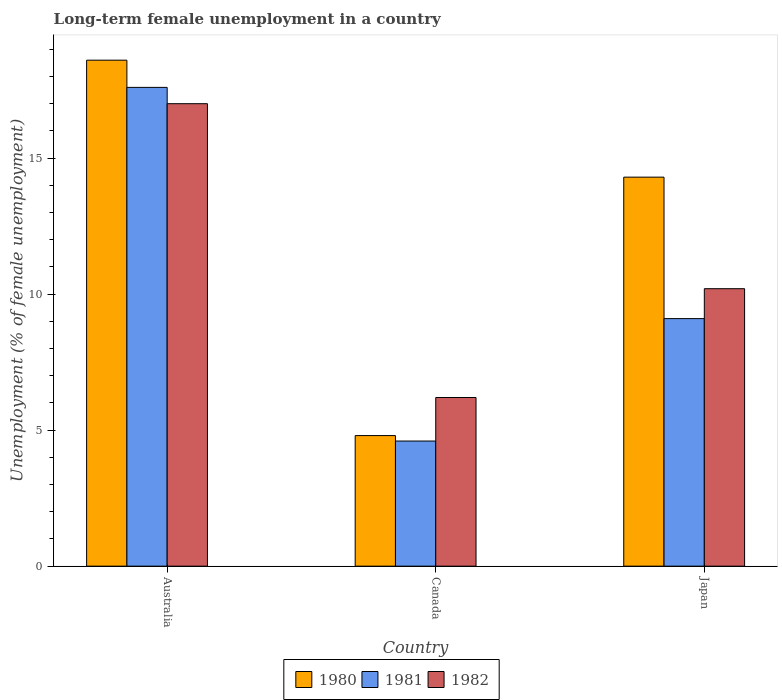How many different coloured bars are there?
Your answer should be compact. 3. How many groups of bars are there?
Provide a succinct answer. 3. Are the number of bars per tick equal to the number of legend labels?
Keep it short and to the point. Yes. Are the number of bars on each tick of the X-axis equal?
Offer a terse response. Yes. How many bars are there on the 3rd tick from the left?
Keep it short and to the point. 3. How many bars are there on the 3rd tick from the right?
Give a very brief answer. 3. In how many cases, is the number of bars for a given country not equal to the number of legend labels?
Your answer should be compact. 0. What is the percentage of long-term unemployed female population in 1981 in Japan?
Your answer should be compact. 9.1. Across all countries, what is the maximum percentage of long-term unemployed female population in 1980?
Give a very brief answer. 18.6. Across all countries, what is the minimum percentage of long-term unemployed female population in 1982?
Offer a very short reply. 6.2. In which country was the percentage of long-term unemployed female population in 1982 maximum?
Give a very brief answer. Australia. What is the total percentage of long-term unemployed female population in 1980 in the graph?
Make the answer very short. 37.7. What is the difference between the percentage of long-term unemployed female population in 1982 in Australia and that in Canada?
Your answer should be very brief. 10.8. What is the difference between the percentage of long-term unemployed female population in 1981 in Australia and the percentage of long-term unemployed female population in 1980 in Canada?
Provide a succinct answer. 12.8. What is the average percentage of long-term unemployed female population in 1982 per country?
Your answer should be very brief. 11.13. What is the difference between the percentage of long-term unemployed female population of/in 1981 and percentage of long-term unemployed female population of/in 1982 in Canada?
Offer a terse response. -1.6. In how many countries, is the percentage of long-term unemployed female population in 1982 greater than 9 %?
Your answer should be very brief. 2. What is the ratio of the percentage of long-term unemployed female population in 1982 in Australia to that in Japan?
Give a very brief answer. 1.67. What is the difference between the highest and the second highest percentage of long-term unemployed female population in 1980?
Your response must be concise. 13.8. What is the difference between the highest and the lowest percentage of long-term unemployed female population in 1980?
Ensure brevity in your answer.  13.8. In how many countries, is the percentage of long-term unemployed female population in 1980 greater than the average percentage of long-term unemployed female population in 1980 taken over all countries?
Offer a very short reply. 2. Is the sum of the percentage of long-term unemployed female population in 1980 in Australia and Canada greater than the maximum percentage of long-term unemployed female population in 1981 across all countries?
Offer a terse response. Yes. How many bars are there?
Your answer should be very brief. 9. Are all the bars in the graph horizontal?
Offer a very short reply. No. What is the difference between two consecutive major ticks on the Y-axis?
Provide a short and direct response. 5. Does the graph contain any zero values?
Your response must be concise. No. Where does the legend appear in the graph?
Provide a short and direct response. Bottom center. How many legend labels are there?
Provide a succinct answer. 3. What is the title of the graph?
Offer a very short reply. Long-term female unemployment in a country. What is the label or title of the Y-axis?
Provide a short and direct response. Unemployment (% of female unemployment). What is the Unemployment (% of female unemployment) in 1980 in Australia?
Give a very brief answer. 18.6. What is the Unemployment (% of female unemployment) of 1981 in Australia?
Your answer should be very brief. 17.6. What is the Unemployment (% of female unemployment) of 1980 in Canada?
Make the answer very short. 4.8. What is the Unemployment (% of female unemployment) in 1981 in Canada?
Keep it short and to the point. 4.6. What is the Unemployment (% of female unemployment) of 1982 in Canada?
Offer a terse response. 6.2. What is the Unemployment (% of female unemployment) of 1980 in Japan?
Offer a terse response. 14.3. What is the Unemployment (% of female unemployment) of 1981 in Japan?
Make the answer very short. 9.1. What is the Unemployment (% of female unemployment) of 1982 in Japan?
Your answer should be compact. 10.2. Across all countries, what is the maximum Unemployment (% of female unemployment) in 1980?
Your answer should be very brief. 18.6. Across all countries, what is the maximum Unemployment (% of female unemployment) of 1981?
Ensure brevity in your answer.  17.6. Across all countries, what is the maximum Unemployment (% of female unemployment) in 1982?
Provide a short and direct response. 17. Across all countries, what is the minimum Unemployment (% of female unemployment) of 1980?
Offer a terse response. 4.8. Across all countries, what is the minimum Unemployment (% of female unemployment) in 1981?
Keep it short and to the point. 4.6. Across all countries, what is the minimum Unemployment (% of female unemployment) in 1982?
Your answer should be compact. 6.2. What is the total Unemployment (% of female unemployment) in 1980 in the graph?
Offer a terse response. 37.7. What is the total Unemployment (% of female unemployment) in 1981 in the graph?
Offer a very short reply. 31.3. What is the total Unemployment (% of female unemployment) of 1982 in the graph?
Your answer should be compact. 33.4. What is the difference between the Unemployment (% of female unemployment) in 1980 in Australia and that in Canada?
Make the answer very short. 13.8. What is the difference between the Unemployment (% of female unemployment) of 1980 in Australia and that in Japan?
Your answer should be compact. 4.3. What is the difference between the Unemployment (% of female unemployment) in 1981 in Australia and that in Japan?
Your answer should be very brief. 8.5. What is the difference between the Unemployment (% of female unemployment) of 1982 in Australia and that in Japan?
Offer a terse response. 6.8. What is the difference between the Unemployment (% of female unemployment) of 1980 in Canada and that in Japan?
Provide a short and direct response. -9.5. What is the difference between the Unemployment (% of female unemployment) in 1981 in Australia and the Unemployment (% of female unemployment) in 1982 in Canada?
Your response must be concise. 11.4. What is the difference between the Unemployment (% of female unemployment) in 1980 in Australia and the Unemployment (% of female unemployment) in 1981 in Japan?
Provide a short and direct response. 9.5. What is the difference between the Unemployment (% of female unemployment) of 1981 in Australia and the Unemployment (% of female unemployment) of 1982 in Japan?
Provide a succinct answer. 7.4. What is the difference between the Unemployment (% of female unemployment) of 1980 in Canada and the Unemployment (% of female unemployment) of 1981 in Japan?
Keep it short and to the point. -4.3. What is the difference between the Unemployment (% of female unemployment) of 1981 in Canada and the Unemployment (% of female unemployment) of 1982 in Japan?
Keep it short and to the point. -5.6. What is the average Unemployment (% of female unemployment) of 1980 per country?
Offer a terse response. 12.57. What is the average Unemployment (% of female unemployment) of 1981 per country?
Make the answer very short. 10.43. What is the average Unemployment (% of female unemployment) of 1982 per country?
Give a very brief answer. 11.13. What is the difference between the Unemployment (% of female unemployment) of 1980 and Unemployment (% of female unemployment) of 1981 in Canada?
Offer a very short reply. 0.2. What is the difference between the Unemployment (% of female unemployment) of 1980 and Unemployment (% of female unemployment) of 1982 in Canada?
Ensure brevity in your answer.  -1.4. What is the difference between the Unemployment (% of female unemployment) of 1981 and Unemployment (% of female unemployment) of 1982 in Canada?
Your answer should be compact. -1.6. What is the difference between the Unemployment (% of female unemployment) of 1980 and Unemployment (% of female unemployment) of 1982 in Japan?
Your answer should be very brief. 4.1. What is the difference between the Unemployment (% of female unemployment) of 1981 and Unemployment (% of female unemployment) of 1982 in Japan?
Provide a short and direct response. -1.1. What is the ratio of the Unemployment (% of female unemployment) of 1980 in Australia to that in Canada?
Keep it short and to the point. 3.88. What is the ratio of the Unemployment (% of female unemployment) in 1981 in Australia to that in Canada?
Your response must be concise. 3.83. What is the ratio of the Unemployment (% of female unemployment) in 1982 in Australia to that in Canada?
Offer a terse response. 2.74. What is the ratio of the Unemployment (% of female unemployment) of 1980 in Australia to that in Japan?
Make the answer very short. 1.3. What is the ratio of the Unemployment (% of female unemployment) in 1981 in Australia to that in Japan?
Keep it short and to the point. 1.93. What is the ratio of the Unemployment (% of female unemployment) in 1980 in Canada to that in Japan?
Keep it short and to the point. 0.34. What is the ratio of the Unemployment (% of female unemployment) of 1981 in Canada to that in Japan?
Make the answer very short. 0.51. What is the ratio of the Unemployment (% of female unemployment) in 1982 in Canada to that in Japan?
Offer a terse response. 0.61. What is the difference between the highest and the second highest Unemployment (% of female unemployment) of 1980?
Keep it short and to the point. 4.3. What is the difference between the highest and the second highest Unemployment (% of female unemployment) of 1981?
Keep it short and to the point. 8.5. What is the difference between the highest and the second highest Unemployment (% of female unemployment) of 1982?
Ensure brevity in your answer.  6.8. What is the difference between the highest and the lowest Unemployment (% of female unemployment) of 1981?
Offer a very short reply. 13. What is the difference between the highest and the lowest Unemployment (% of female unemployment) of 1982?
Your answer should be compact. 10.8. 